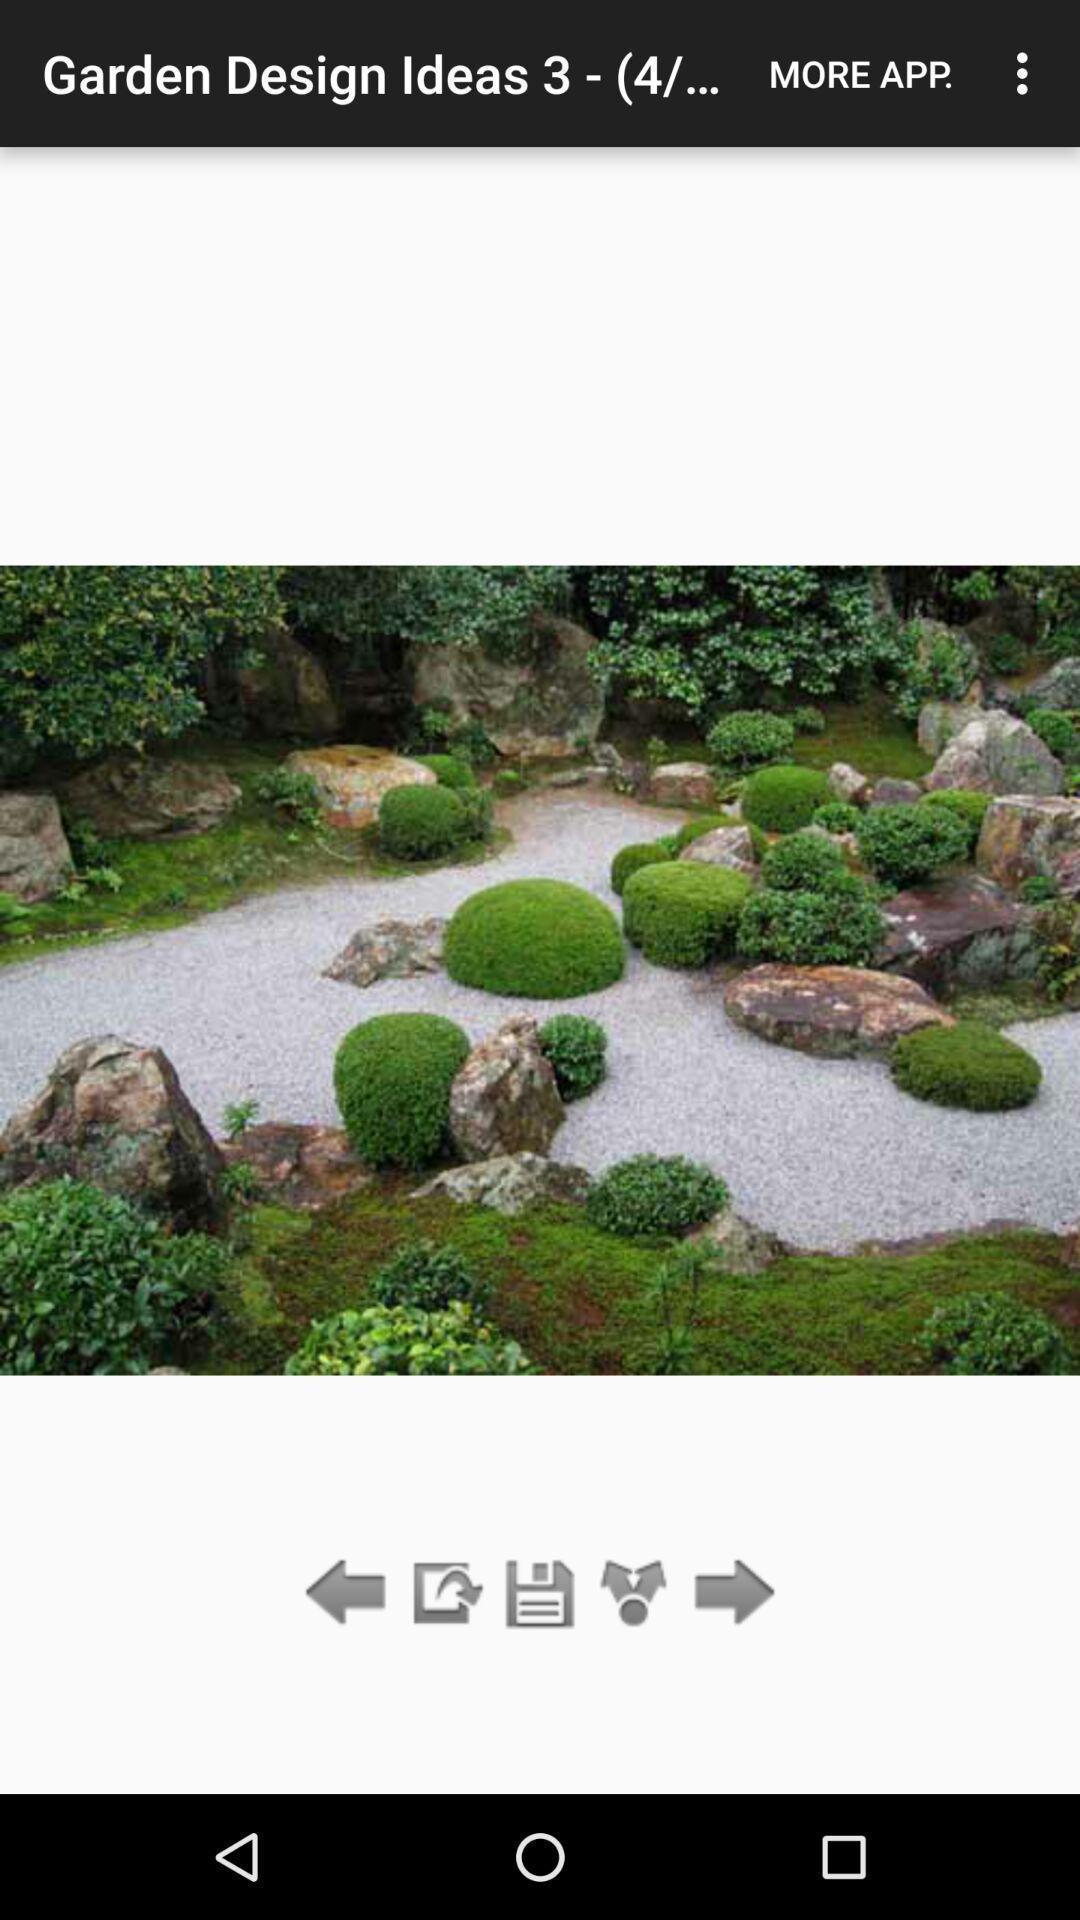Describe this image in words. Screen shows garden design ideas. 